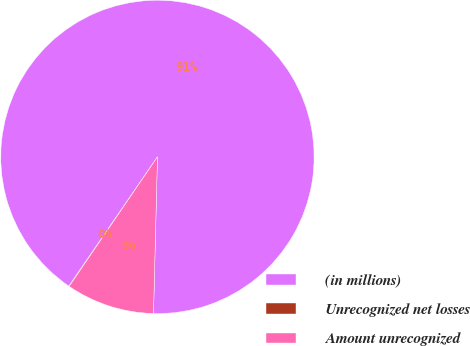Convert chart. <chart><loc_0><loc_0><loc_500><loc_500><pie_chart><fcel>(in millions)<fcel>Unrecognized net losses<fcel>Amount unrecognized<nl><fcel>90.83%<fcel>0.05%<fcel>9.12%<nl></chart> 